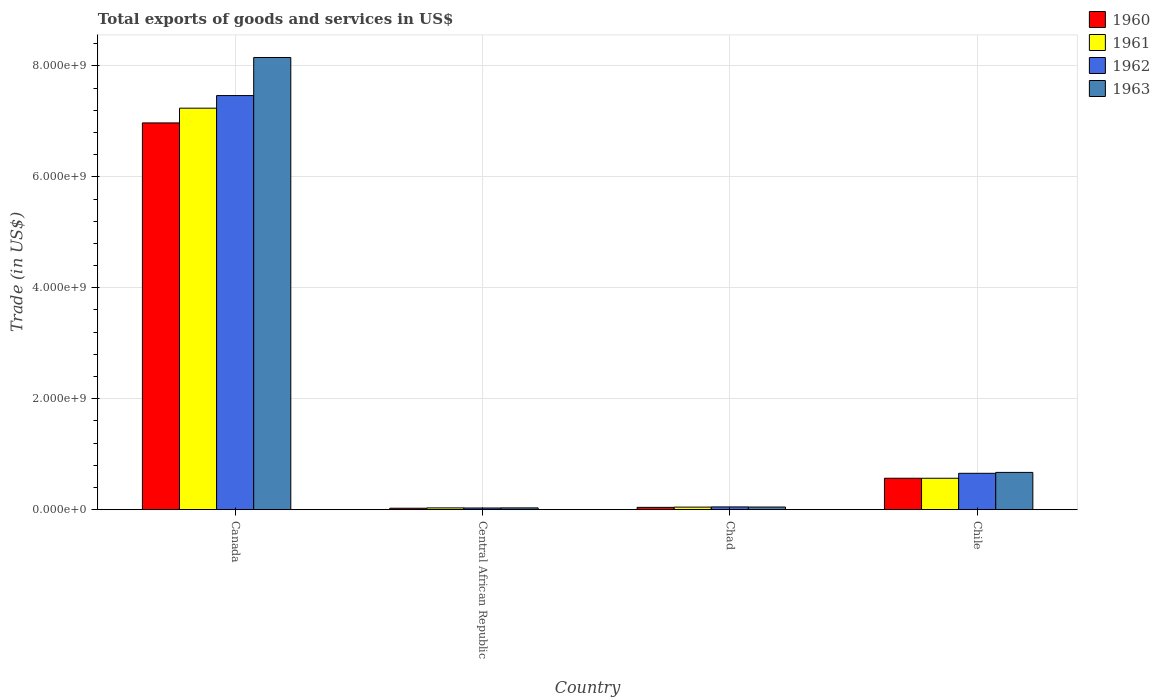How many different coloured bars are there?
Your answer should be very brief. 4. Are the number of bars per tick equal to the number of legend labels?
Offer a very short reply. Yes. How many bars are there on the 3rd tick from the left?
Your response must be concise. 4. How many bars are there on the 1st tick from the right?
Provide a short and direct response. 4. What is the label of the 3rd group of bars from the left?
Your answer should be compact. Chad. What is the total exports of goods and services in 1962 in Chad?
Give a very brief answer. 5.02e+07. Across all countries, what is the maximum total exports of goods and services in 1962?
Your answer should be compact. 7.46e+09. Across all countries, what is the minimum total exports of goods and services in 1961?
Your answer should be very brief. 3.26e+07. In which country was the total exports of goods and services in 1960 minimum?
Provide a short and direct response. Central African Republic. What is the total total exports of goods and services in 1961 in the graph?
Your answer should be compact. 7.88e+09. What is the difference between the total exports of goods and services in 1961 in Central African Republic and that in Chile?
Ensure brevity in your answer.  -5.34e+08. What is the difference between the total exports of goods and services in 1960 in Central African Republic and the total exports of goods and services in 1963 in Canada?
Offer a terse response. -8.13e+09. What is the average total exports of goods and services in 1963 per country?
Your answer should be very brief. 2.23e+09. What is the difference between the total exports of goods and services of/in 1960 and total exports of goods and services of/in 1961 in Chile?
Your answer should be compact. 5.40e+05. In how many countries, is the total exports of goods and services in 1961 greater than 4400000000 US$?
Provide a succinct answer. 1. What is the ratio of the total exports of goods and services in 1960 in Chad to that in Chile?
Your answer should be very brief. 0.07. Is the difference between the total exports of goods and services in 1960 in Canada and Central African Republic greater than the difference between the total exports of goods and services in 1961 in Canada and Central African Republic?
Give a very brief answer. No. What is the difference between the highest and the second highest total exports of goods and services in 1960?
Make the answer very short. 6.93e+09. What is the difference between the highest and the lowest total exports of goods and services in 1960?
Keep it short and to the point. 6.95e+09. In how many countries, is the total exports of goods and services in 1963 greater than the average total exports of goods and services in 1963 taken over all countries?
Give a very brief answer. 1. What does the 1st bar from the right in Chile represents?
Offer a very short reply. 1963. How many bars are there?
Provide a succinct answer. 16. Are all the bars in the graph horizontal?
Your response must be concise. No. What is the difference between two consecutive major ticks on the Y-axis?
Give a very brief answer. 2.00e+09. Are the values on the major ticks of Y-axis written in scientific E-notation?
Offer a terse response. Yes. Does the graph contain grids?
Provide a short and direct response. Yes. Where does the legend appear in the graph?
Provide a short and direct response. Top right. How many legend labels are there?
Provide a short and direct response. 4. How are the legend labels stacked?
Your answer should be very brief. Vertical. What is the title of the graph?
Offer a terse response. Total exports of goods and services in US$. Does "1982" appear as one of the legend labels in the graph?
Offer a terse response. No. What is the label or title of the X-axis?
Provide a succinct answer. Country. What is the label or title of the Y-axis?
Keep it short and to the point. Trade (in US$). What is the Trade (in US$) of 1960 in Canada?
Make the answer very short. 6.97e+09. What is the Trade (in US$) in 1961 in Canada?
Your answer should be compact. 7.24e+09. What is the Trade (in US$) in 1962 in Canada?
Keep it short and to the point. 7.46e+09. What is the Trade (in US$) of 1963 in Canada?
Make the answer very short. 8.15e+09. What is the Trade (in US$) of 1960 in Central African Republic?
Give a very brief answer. 2.61e+07. What is the Trade (in US$) in 1961 in Central African Republic?
Provide a short and direct response. 3.26e+07. What is the Trade (in US$) of 1962 in Central African Republic?
Give a very brief answer. 3.06e+07. What is the Trade (in US$) in 1963 in Central African Republic?
Ensure brevity in your answer.  3.27e+07. What is the Trade (in US$) of 1960 in Chad?
Offer a terse response. 4.20e+07. What is the Trade (in US$) in 1961 in Chad?
Provide a short and direct response. 4.65e+07. What is the Trade (in US$) of 1962 in Chad?
Provide a short and direct response. 5.02e+07. What is the Trade (in US$) in 1963 in Chad?
Provide a short and direct response. 4.81e+07. What is the Trade (in US$) of 1960 in Chile?
Offer a terse response. 5.67e+08. What is the Trade (in US$) of 1961 in Chile?
Your response must be concise. 5.67e+08. What is the Trade (in US$) in 1962 in Chile?
Provide a short and direct response. 6.56e+08. What is the Trade (in US$) in 1963 in Chile?
Ensure brevity in your answer.  6.72e+08. Across all countries, what is the maximum Trade (in US$) in 1960?
Provide a succinct answer. 6.97e+09. Across all countries, what is the maximum Trade (in US$) in 1961?
Offer a very short reply. 7.24e+09. Across all countries, what is the maximum Trade (in US$) in 1962?
Keep it short and to the point. 7.46e+09. Across all countries, what is the maximum Trade (in US$) of 1963?
Offer a very short reply. 8.15e+09. Across all countries, what is the minimum Trade (in US$) of 1960?
Ensure brevity in your answer.  2.61e+07. Across all countries, what is the minimum Trade (in US$) of 1961?
Your answer should be very brief. 3.26e+07. Across all countries, what is the minimum Trade (in US$) in 1962?
Your answer should be very brief. 3.06e+07. Across all countries, what is the minimum Trade (in US$) in 1963?
Give a very brief answer. 3.27e+07. What is the total Trade (in US$) in 1960 in the graph?
Your answer should be compact. 7.61e+09. What is the total Trade (in US$) of 1961 in the graph?
Your response must be concise. 7.88e+09. What is the total Trade (in US$) in 1962 in the graph?
Ensure brevity in your answer.  8.20e+09. What is the total Trade (in US$) in 1963 in the graph?
Ensure brevity in your answer.  8.90e+09. What is the difference between the Trade (in US$) in 1960 in Canada and that in Central African Republic?
Make the answer very short. 6.95e+09. What is the difference between the Trade (in US$) in 1961 in Canada and that in Central African Republic?
Your answer should be compact. 7.20e+09. What is the difference between the Trade (in US$) in 1962 in Canada and that in Central African Republic?
Your answer should be very brief. 7.43e+09. What is the difference between the Trade (in US$) of 1963 in Canada and that in Central African Republic?
Keep it short and to the point. 8.12e+09. What is the difference between the Trade (in US$) in 1960 in Canada and that in Chad?
Your answer should be very brief. 6.93e+09. What is the difference between the Trade (in US$) of 1961 in Canada and that in Chad?
Keep it short and to the point. 7.19e+09. What is the difference between the Trade (in US$) in 1962 in Canada and that in Chad?
Offer a terse response. 7.41e+09. What is the difference between the Trade (in US$) in 1963 in Canada and that in Chad?
Ensure brevity in your answer.  8.10e+09. What is the difference between the Trade (in US$) of 1960 in Canada and that in Chile?
Your answer should be compact. 6.40e+09. What is the difference between the Trade (in US$) in 1961 in Canada and that in Chile?
Your answer should be compact. 6.67e+09. What is the difference between the Trade (in US$) in 1962 in Canada and that in Chile?
Provide a succinct answer. 6.81e+09. What is the difference between the Trade (in US$) of 1963 in Canada and that in Chile?
Provide a short and direct response. 7.48e+09. What is the difference between the Trade (in US$) of 1960 in Central African Republic and that in Chad?
Give a very brief answer. -1.59e+07. What is the difference between the Trade (in US$) of 1961 in Central African Republic and that in Chad?
Give a very brief answer. -1.38e+07. What is the difference between the Trade (in US$) in 1962 in Central African Republic and that in Chad?
Offer a terse response. -1.96e+07. What is the difference between the Trade (in US$) of 1963 in Central African Republic and that in Chad?
Provide a short and direct response. -1.55e+07. What is the difference between the Trade (in US$) in 1960 in Central African Republic and that in Chile?
Your answer should be very brief. -5.41e+08. What is the difference between the Trade (in US$) of 1961 in Central African Republic and that in Chile?
Provide a succinct answer. -5.34e+08. What is the difference between the Trade (in US$) in 1962 in Central African Republic and that in Chile?
Provide a short and direct response. -6.25e+08. What is the difference between the Trade (in US$) of 1963 in Central African Republic and that in Chile?
Offer a terse response. -6.40e+08. What is the difference between the Trade (in US$) in 1960 in Chad and that in Chile?
Ensure brevity in your answer.  -5.25e+08. What is the difference between the Trade (in US$) of 1961 in Chad and that in Chile?
Provide a succinct answer. -5.20e+08. What is the difference between the Trade (in US$) in 1962 in Chad and that in Chile?
Keep it short and to the point. -6.06e+08. What is the difference between the Trade (in US$) of 1963 in Chad and that in Chile?
Provide a succinct answer. -6.24e+08. What is the difference between the Trade (in US$) in 1960 in Canada and the Trade (in US$) in 1961 in Central African Republic?
Give a very brief answer. 6.94e+09. What is the difference between the Trade (in US$) of 1960 in Canada and the Trade (in US$) of 1962 in Central African Republic?
Ensure brevity in your answer.  6.94e+09. What is the difference between the Trade (in US$) of 1960 in Canada and the Trade (in US$) of 1963 in Central African Republic?
Keep it short and to the point. 6.94e+09. What is the difference between the Trade (in US$) of 1961 in Canada and the Trade (in US$) of 1962 in Central African Republic?
Ensure brevity in your answer.  7.21e+09. What is the difference between the Trade (in US$) of 1961 in Canada and the Trade (in US$) of 1963 in Central African Republic?
Your answer should be compact. 7.20e+09. What is the difference between the Trade (in US$) of 1962 in Canada and the Trade (in US$) of 1963 in Central African Republic?
Provide a succinct answer. 7.43e+09. What is the difference between the Trade (in US$) of 1960 in Canada and the Trade (in US$) of 1961 in Chad?
Offer a terse response. 6.93e+09. What is the difference between the Trade (in US$) of 1960 in Canada and the Trade (in US$) of 1962 in Chad?
Offer a terse response. 6.92e+09. What is the difference between the Trade (in US$) in 1960 in Canada and the Trade (in US$) in 1963 in Chad?
Your answer should be very brief. 6.92e+09. What is the difference between the Trade (in US$) in 1961 in Canada and the Trade (in US$) in 1962 in Chad?
Ensure brevity in your answer.  7.19e+09. What is the difference between the Trade (in US$) of 1961 in Canada and the Trade (in US$) of 1963 in Chad?
Your answer should be very brief. 7.19e+09. What is the difference between the Trade (in US$) of 1962 in Canada and the Trade (in US$) of 1963 in Chad?
Provide a short and direct response. 7.42e+09. What is the difference between the Trade (in US$) in 1960 in Canada and the Trade (in US$) in 1961 in Chile?
Offer a very short reply. 6.41e+09. What is the difference between the Trade (in US$) of 1960 in Canada and the Trade (in US$) of 1962 in Chile?
Offer a very short reply. 6.32e+09. What is the difference between the Trade (in US$) of 1960 in Canada and the Trade (in US$) of 1963 in Chile?
Provide a succinct answer. 6.30e+09. What is the difference between the Trade (in US$) in 1961 in Canada and the Trade (in US$) in 1962 in Chile?
Make the answer very short. 6.58e+09. What is the difference between the Trade (in US$) of 1961 in Canada and the Trade (in US$) of 1963 in Chile?
Give a very brief answer. 6.57e+09. What is the difference between the Trade (in US$) of 1962 in Canada and the Trade (in US$) of 1963 in Chile?
Your answer should be very brief. 6.79e+09. What is the difference between the Trade (in US$) in 1960 in Central African Republic and the Trade (in US$) in 1961 in Chad?
Provide a succinct answer. -2.04e+07. What is the difference between the Trade (in US$) in 1960 in Central African Republic and the Trade (in US$) in 1962 in Chad?
Your answer should be compact. -2.41e+07. What is the difference between the Trade (in US$) of 1960 in Central African Republic and the Trade (in US$) of 1963 in Chad?
Keep it short and to the point. -2.20e+07. What is the difference between the Trade (in US$) in 1961 in Central African Republic and the Trade (in US$) in 1962 in Chad?
Your response must be concise. -1.76e+07. What is the difference between the Trade (in US$) in 1961 in Central African Republic and the Trade (in US$) in 1963 in Chad?
Keep it short and to the point. -1.55e+07. What is the difference between the Trade (in US$) of 1962 in Central African Republic and the Trade (in US$) of 1963 in Chad?
Keep it short and to the point. -1.75e+07. What is the difference between the Trade (in US$) in 1960 in Central African Republic and the Trade (in US$) in 1961 in Chile?
Keep it short and to the point. -5.40e+08. What is the difference between the Trade (in US$) in 1960 in Central African Republic and the Trade (in US$) in 1962 in Chile?
Your response must be concise. -6.30e+08. What is the difference between the Trade (in US$) in 1960 in Central African Republic and the Trade (in US$) in 1963 in Chile?
Your answer should be very brief. -6.46e+08. What is the difference between the Trade (in US$) in 1961 in Central African Republic and the Trade (in US$) in 1962 in Chile?
Offer a terse response. -6.23e+08. What is the difference between the Trade (in US$) in 1961 in Central African Republic and the Trade (in US$) in 1963 in Chile?
Provide a succinct answer. -6.40e+08. What is the difference between the Trade (in US$) in 1962 in Central African Republic and the Trade (in US$) in 1963 in Chile?
Provide a succinct answer. -6.42e+08. What is the difference between the Trade (in US$) of 1960 in Chad and the Trade (in US$) of 1961 in Chile?
Provide a short and direct response. -5.25e+08. What is the difference between the Trade (in US$) in 1960 in Chad and the Trade (in US$) in 1962 in Chile?
Give a very brief answer. -6.14e+08. What is the difference between the Trade (in US$) of 1960 in Chad and the Trade (in US$) of 1963 in Chile?
Keep it short and to the point. -6.30e+08. What is the difference between the Trade (in US$) of 1961 in Chad and the Trade (in US$) of 1962 in Chile?
Ensure brevity in your answer.  -6.10e+08. What is the difference between the Trade (in US$) in 1961 in Chad and the Trade (in US$) in 1963 in Chile?
Your answer should be very brief. -6.26e+08. What is the difference between the Trade (in US$) in 1962 in Chad and the Trade (in US$) in 1963 in Chile?
Your answer should be compact. -6.22e+08. What is the average Trade (in US$) in 1960 per country?
Give a very brief answer. 1.90e+09. What is the average Trade (in US$) in 1961 per country?
Keep it short and to the point. 1.97e+09. What is the average Trade (in US$) of 1962 per country?
Make the answer very short. 2.05e+09. What is the average Trade (in US$) of 1963 per country?
Provide a succinct answer. 2.23e+09. What is the difference between the Trade (in US$) in 1960 and Trade (in US$) in 1961 in Canada?
Offer a very short reply. -2.66e+08. What is the difference between the Trade (in US$) in 1960 and Trade (in US$) in 1962 in Canada?
Provide a short and direct response. -4.93e+08. What is the difference between the Trade (in US$) of 1960 and Trade (in US$) of 1963 in Canada?
Offer a very short reply. -1.18e+09. What is the difference between the Trade (in US$) in 1961 and Trade (in US$) in 1962 in Canada?
Give a very brief answer. -2.27e+08. What is the difference between the Trade (in US$) in 1961 and Trade (in US$) in 1963 in Canada?
Your answer should be very brief. -9.14e+08. What is the difference between the Trade (in US$) in 1962 and Trade (in US$) in 1963 in Canada?
Offer a terse response. -6.86e+08. What is the difference between the Trade (in US$) in 1960 and Trade (in US$) in 1961 in Central African Republic?
Ensure brevity in your answer.  -6.52e+06. What is the difference between the Trade (in US$) in 1960 and Trade (in US$) in 1962 in Central African Republic?
Your answer should be very brief. -4.51e+06. What is the difference between the Trade (in US$) in 1960 and Trade (in US$) in 1963 in Central African Republic?
Your answer should be very brief. -6.55e+06. What is the difference between the Trade (in US$) in 1961 and Trade (in US$) in 1962 in Central African Republic?
Keep it short and to the point. 2.01e+06. What is the difference between the Trade (in US$) in 1961 and Trade (in US$) in 1963 in Central African Republic?
Your answer should be very brief. -3.24e+04. What is the difference between the Trade (in US$) of 1962 and Trade (in US$) of 1963 in Central African Republic?
Offer a very short reply. -2.04e+06. What is the difference between the Trade (in US$) in 1960 and Trade (in US$) in 1961 in Chad?
Provide a succinct answer. -4.47e+06. What is the difference between the Trade (in US$) of 1960 and Trade (in US$) of 1962 in Chad?
Your answer should be very brief. -8.19e+06. What is the difference between the Trade (in US$) in 1960 and Trade (in US$) in 1963 in Chad?
Offer a terse response. -6.15e+06. What is the difference between the Trade (in US$) in 1961 and Trade (in US$) in 1962 in Chad?
Offer a terse response. -3.72e+06. What is the difference between the Trade (in US$) in 1961 and Trade (in US$) in 1963 in Chad?
Provide a succinct answer. -1.68e+06. What is the difference between the Trade (in US$) in 1962 and Trade (in US$) in 1963 in Chad?
Make the answer very short. 2.04e+06. What is the difference between the Trade (in US$) in 1960 and Trade (in US$) in 1961 in Chile?
Keep it short and to the point. 5.40e+05. What is the difference between the Trade (in US$) of 1960 and Trade (in US$) of 1962 in Chile?
Give a very brief answer. -8.89e+07. What is the difference between the Trade (in US$) in 1960 and Trade (in US$) in 1963 in Chile?
Your response must be concise. -1.05e+08. What is the difference between the Trade (in US$) of 1961 and Trade (in US$) of 1962 in Chile?
Your response must be concise. -8.94e+07. What is the difference between the Trade (in US$) of 1961 and Trade (in US$) of 1963 in Chile?
Provide a short and direct response. -1.06e+08. What is the difference between the Trade (in US$) of 1962 and Trade (in US$) of 1963 in Chile?
Make the answer very short. -1.64e+07. What is the ratio of the Trade (in US$) in 1960 in Canada to that in Central African Republic?
Give a very brief answer. 267.11. What is the ratio of the Trade (in US$) in 1961 in Canada to that in Central African Republic?
Provide a succinct answer. 221.88. What is the ratio of the Trade (in US$) in 1962 in Canada to that in Central African Republic?
Keep it short and to the point. 243.87. What is the ratio of the Trade (in US$) of 1963 in Canada to that in Central African Republic?
Keep it short and to the point. 249.65. What is the ratio of the Trade (in US$) in 1960 in Canada to that in Chad?
Your response must be concise. 166.05. What is the ratio of the Trade (in US$) of 1961 in Canada to that in Chad?
Ensure brevity in your answer.  155.78. What is the ratio of the Trade (in US$) in 1962 in Canada to that in Chad?
Provide a succinct answer. 148.77. What is the ratio of the Trade (in US$) in 1963 in Canada to that in Chad?
Keep it short and to the point. 169.33. What is the ratio of the Trade (in US$) in 1960 in Canada to that in Chile?
Provide a short and direct response. 12.29. What is the ratio of the Trade (in US$) in 1961 in Canada to that in Chile?
Ensure brevity in your answer.  12.77. What is the ratio of the Trade (in US$) in 1962 in Canada to that in Chile?
Your response must be concise. 11.38. What is the ratio of the Trade (in US$) in 1963 in Canada to that in Chile?
Your response must be concise. 12.12. What is the ratio of the Trade (in US$) of 1960 in Central African Republic to that in Chad?
Your response must be concise. 0.62. What is the ratio of the Trade (in US$) in 1961 in Central African Republic to that in Chad?
Keep it short and to the point. 0.7. What is the ratio of the Trade (in US$) in 1962 in Central African Republic to that in Chad?
Offer a very short reply. 0.61. What is the ratio of the Trade (in US$) in 1963 in Central African Republic to that in Chad?
Your answer should be very brief. 0.68. What is the ratio of the Trade (in US$) in 1960 in Central African Republic to that in Chile?
Offer a very short reply. 0.05. What is the ratio of the Trade (in US$) in 1961 in Central African Republic to that in Chile?
Your answer should be compact. 0.06. What is the ratio of the Trade (in US$) of 1962 in Central African Republic to that in Chile?
Give a very brief answer. 0.05. What is the ratio of the Trade (in US$) in 1963 in Central African Republic to that in Chile?
Give a very brief answer. 0.05. What is the ratio of the Trade (in US$) in 1960 in Chad to that in Chile?
Give a very brief answer. 0.07. What is the ratio of the Trade (in US$) in 1961 in Chad to that in Chile?
Give a very brief answer. 0.08. What is the ratio of the Trade (in US$) of 1962 in Chad to that in Chile?
Provide a short and direct response. 0.08. What is the ratio of the Trade (in US$) of 1963 in Chad to that in Chile?
Provide a succinct answer. 0.07. What is the difference between the highest and the second highest Trade (in US$) of 1960?
Make the answer very short. 6.40e+09. What is the difference between the highest and the second highest Trade (in US$) in 1961?
Offer a terse response. 6.67e+09. What is the difference between the highest and the second highest Trade (in US$) of 1962?
Provide a succinct answer. 6.81e+09. What is the difference between the highest and the second highest Trade (in US$) of 1963?
Your answer should be compact. 7.48e+09. What is the difference between the highest and the lowest Trade (in US$) in 1960?
Your answer should be very brief. 6.95e+09. What is the difference between the highest and the lowest Trade (in US$) in 1961?
Offer a very short reply. 7.20e+09. What is the difference between the highest and the lowest Trade (in US$) in 1962?
Your response must be concise. 7.43e+09. What is the difference between the highest and the lowest Trade (in US$) of 1963?
Provide a short and direct response. 8.12e+09. 